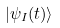Convert formula to latex. <formula><loc_0><loc_0><loc_500><loc_500>| \psi _ { I } ( t ) \rangle</formula> 